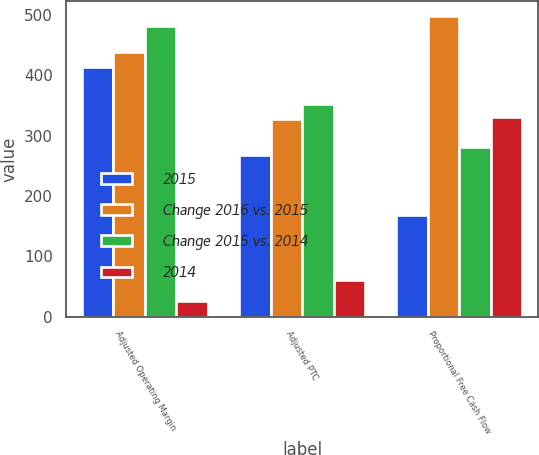Convert chart to OTSL. <chart><loc_0><loc_0><loc_500><loc_500><stacked_bar_chart><ecel><fcel>Adjusted Operating Margin<fcel>Adjusted PTC<fcel>Proportional Free Cash Flow<nl><fcel>2015<fcel>413<fcel>267<fcel>168<nl><fcel>Change 2016 vs. 2015<fcel>438<fcel>327<fcel>498<nl><fcel>Change 2015 vs. 2014<fcel>482<fcel>352<fcel>281<nl><fcel>2014<fcel>25<fcel>60<fcel>330<nl></chart> 